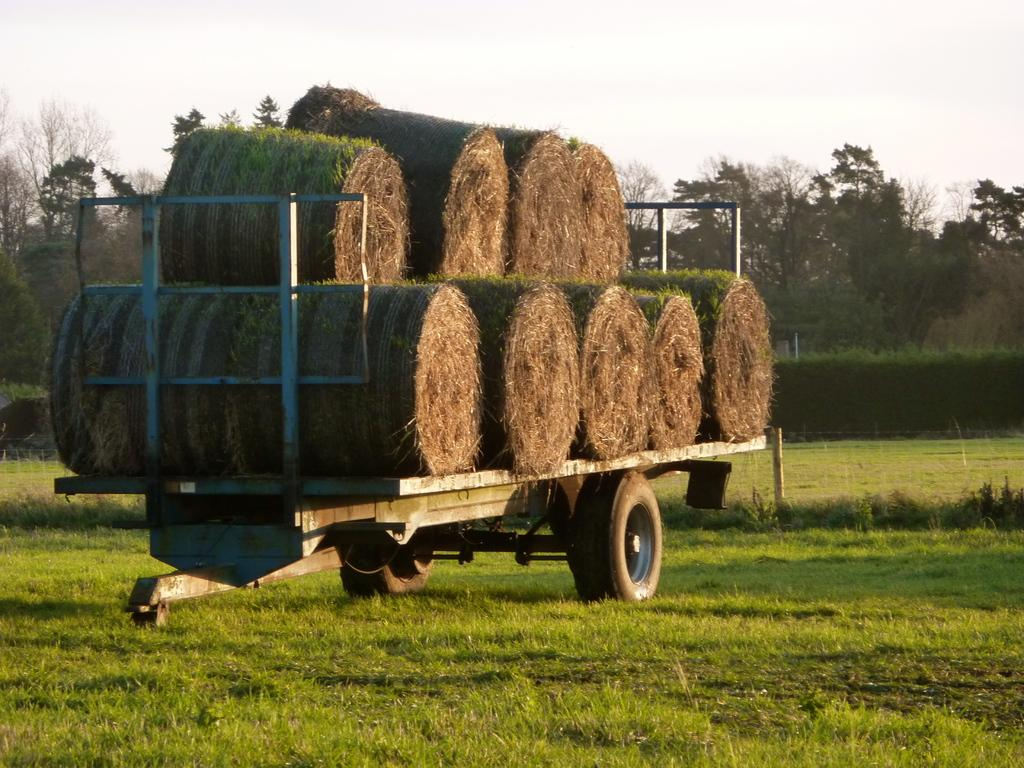What type of vehicle is in the image? The specific type of vehicle is not mentioned, but there is a vehicle present in the image. What is on top of the vehicle? Hay is present on the vehicle. What type of vegetation can be seen in the image? There is grass visible in the image. What other objects can be seen in the image? There is a tree and a pole in the image. What is visible in the background of the image? The sky is visible in the image. What type of kettle is hanging from the tree in the image? There is no kettle present in the image; it only features a vehicle, hay, grass, a tree, a pole, and the sky. Can you tell me how many quartz rocks are scattered around the vehicle in the image? There is no mention of quartz rocks in the image; it only features a vehicle, hay, grass, a tree, a pole, and the sky. 